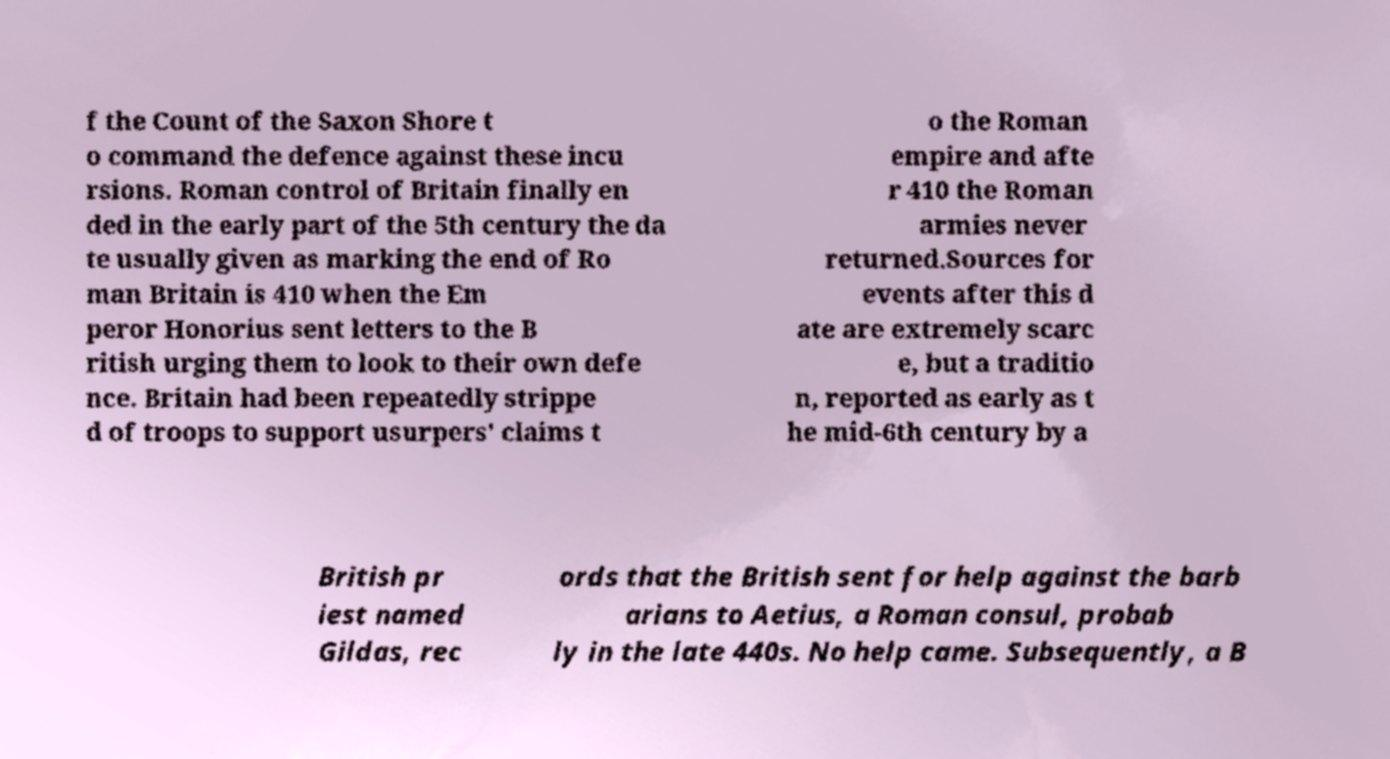I need the written content from this picture converted into text. Can you do that? f the Count of the Saxon Shore t o command the defence against these incu rsions. Roman control of Britain finally en ded in the early part of the 5th century the da te usually given as marking the end of Ro man Britain is 410 when the Em peror Honorius sent letters to the B ritish urging them to look to their own defe nce. Britain had been repeatedly strippe d of troops to support usurpers' claims t o the Roman empire and afte r 410 the Roman armies never returned.Sources for events after this d ate are extremely scarc e, but a traditio n, reported as early as t he mid-6th century by a British pr iest named Gildas, rec ords that the British sent for help against the barb arians to Aetius, a Roman consul, probab ly in the late 440s. No help came. Subsequently, a B 